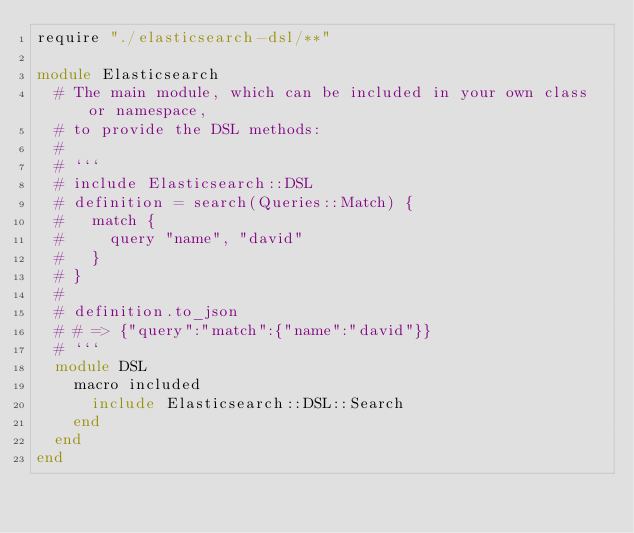<code> <loc_0><loc_0><loc_500><loc_500><_Crystal_>require "./elasticsearch-dsl/**"

module Elasticsearch
  # The main module, which can be included in your own class or namespace,
  # to provide the DSL methods:
  #
  # ```
  # include Elasticsearch::DSL
  # definition = search(Queries::Match) {
  #   match {
  #     query "name", "david"
  #   }
  # }
  #
  # definition.to_json
  # # => {"query":"match":{"name":"david"}}
  # ```
  module DSL
    macro included
      include Elasticsearch::DSL::Search
    end
  end
end
</code> 